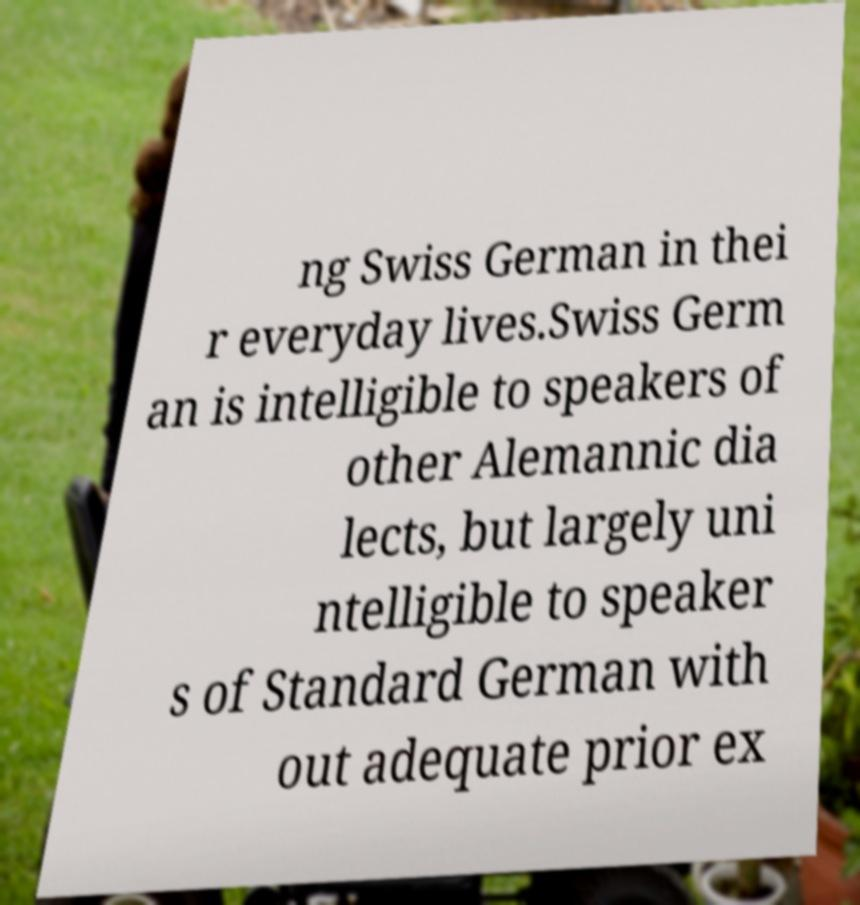Please identify and transcribe the text found in this image. ng Swiss German in thei r everyday lives.Swiss Germ an is intelligible to speakers of other Alemannic dia lects, but largely uni ntelligible to speaker s of Standard German with out adequate prior ex 